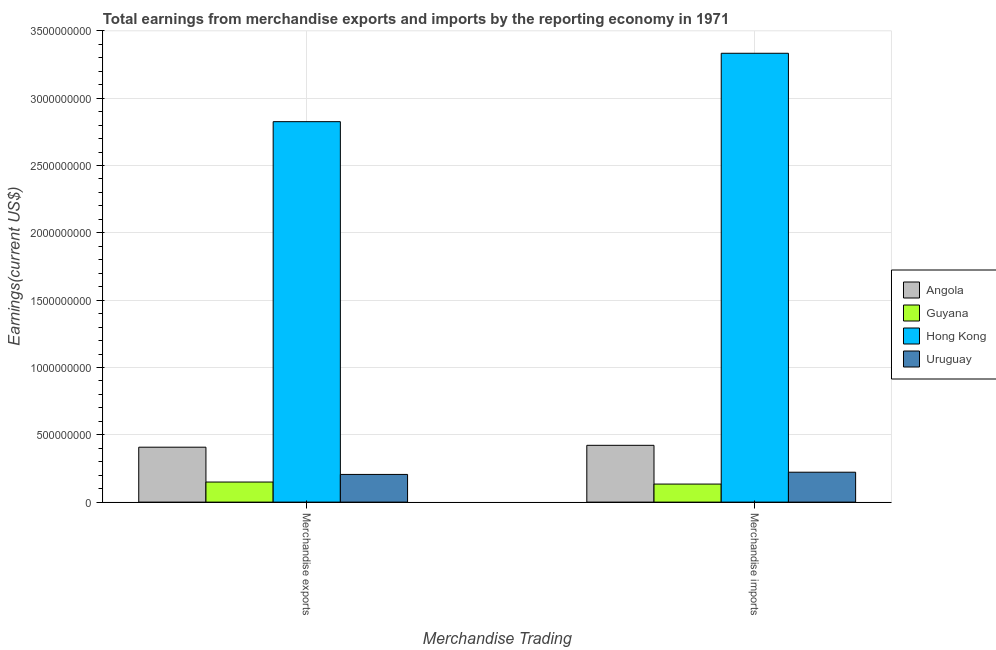How many different coloured bars are there?
Provide a short and direct response. 4. How many groups of bars are there?
Your answer should be very brief. 2. Are the number of bars per tick equal to the number of legend labels?
Your answer should be compact. Yes. Are the number of bars on each tick of the X-axis equal?
Make the answer very short. Yes. What is the label of the 2nd group of bars from the left?
Your answer should be very brief. Merchandise imports. What is the earnings from merchandise imports in Hong Kong?
Your response must be concise. 3.33e+09. Across all countries, what is the maximum earnings from merchandise imports?
Make the answer very short. 3.33e+09. Across all countries, what is the minimum earnings from merchandise exports?
Provide a succinct answer. 1.49e+08. In which country was the earnings from merchandise imports maximum?
Provide a succinct answer. Hong Kong. In which country was the earnings from merchandise exports minimum?
Provide a short and direct response. Guyana. What is the total earnings from merchandise exports in the graph?
Your answer should be very brief. 3.59e+09. What is the difference between the earnings from merchandise imports in Guyana and that in Angola?
Your response must be concise. -2.88e+08. What is the difference between the earnings from merchandise imports in Angola and the earnings from merchandise exports in Uruguay?
Keep it short and to the point. 2.16e+08. What is the average earnings from merchandise imports per country?
Offer a very short reply. 1.03e+09. What is the difference between the earnings from merchandise imports and earnings from merchandise exports in Angola?
Give a very brief answer. 1.39e+07. In how many countries, is the earnings from merchandise exports greater than 600000000 US$?
Offer a terse response. 1. What is the ratio of the earnings from merchandise exports in Uruguay to that in Hong Kong?
Your response must be concise. 0.07. In how many countries, is the earnings from merchandise exports greater than the average earnings from merchandise exports taken over all countries?
Your answer should be very brief. 1. What does the 1st bar from the left in Merchandise exports represents?
Your response must be concise. Angola. What does the 2nd bar from the right in Merchandise imports represents?
Provide a short and direct response. Hong Kong. How many bars are there?
Provide a succinct answer. 8. Are all the bars in the graph horizontal?
Make the answer very short. No. How many countries are there in the graph?
Offer a very short reply. 4. What is the difference between two consecutive major ticks on the Y-axis?
Make the answer very short. 5.00e+08. Are the values on the major ticks of Y-axis written in scientific E-notation?
Provide a succinct answer. No. Does the graph contain any zero values?
Provide a succinct answer. No. Does the graph contain grids?
Offer a very short reply. Yes. How are the legend labels stacked?
Offer a terse response. Vertical. What is the title of the graph?
Offer a terse response. Total earnings from merchandise exports and imports by the reporting economy in 1971. Does "Nepal" appear as one of the legend labels in the graph?
Offer a terse response. No. What is the label or title of the X-axis?
Your answer should be very brief. Merchandise Trading. What is the label or title of the Y-axis?
Ensure brevity in your answer.  Earnings(current US$). What is the Earnings(current US$) in Angola in Merchandise exports?
Ensure brevity in your answer.  4.08e+08. What is the Earnings(current US$) in Guyana in Merchandise exports?
Keep it short and to the point. 1.49e+08. What is the Earnings(current US$) of Hong Kong in Merchandise exports?
Make the answer very short. 2.83e+09. What is the Earnings(current US$) in Uruguay in Merchandise exports?
Provide a short and direct response. 2.06e+08. What is the Earnings(current US$) of Angola in Merchandise imports?
Keep it short and to the point. 4.22e+08. What is the Earnings(current US$) of Guyana in Merchandise imports?
Make the answer very short. 1.34e+08. What is the Earnings(current US$) in Hong Kong in Merchandise imports?
Your response must be concise. 3.33e+09. What is the Earnings(current US$) of Uruguay in Merchandise imports?
Provide a short and direct response. 2.22e+08. Across all Merchandise Trading, what is the maximum Earnings(current US$) in Angola?
Make the answer very short. 4.22e+08. Across all Merchandise Trading, what is the maximum Earnings(current US$) of Guyana?
Make the answer very short. 1.49e+08. Across all Merchandise Trading, what is the maximum Earnings(current US$) of Hong Kong?
Offer a terse response. 3.33e+09. Across all Merchandise Trading, what is the maximum Earnings(current US$) of Uruguay?
Your response must be concise. 2.22e+08. Across all Merchandise Trading, what is the minimum Earnings(current US$) of Angola?
Keep it short and to the point. 4.08e+08. Across all Merchandise Trading, what is the minimum Earnings(current US$) of Guyana?
Keep it short and to the point. 1.34e+08. Across all Merchandise Trading, what is the minimum Earnings(current US$) in Hong Kong?
Your answer should be very brief. 2.83e+09. Across all Merchandise Trading, what is the minimum Earnings(current US$) of Uruguay?
Provide a short and direct response. 2.06e+08. What is the total Earnings(current US$) of Angola in the graph?
Provide a short and direct response. 8.30e+08. What is the total Earnings(current US$) of Guyana in the graph?
Your answer should be compact. 2.83e+08. What is the total Earnings(current US$) of Hong Kong in the graph?
Your response must be concise. 6.16e+09. What is the total Earnings(current US$) of Uruguay in the graph?
Offer a terse response. 4.28e+08. What is the difference between the Earnings(current US$) of Angola in Merchandise exports and that in Merchandise imports?
Provide a short and direct response. -1.39e+07. What is the difference between the Earnings(current US$) in Guyana in Merchandise exports and that in Merchandise imports?
Your response must be concise. 1.51e+07. What is the difference between the Earnings(current US$) in Hong Kong in Merchandise exports and that in Merchandise imports?
Make the answer very short. -5.08e+08. What is the difference between the Earnings(current US$) in Uruguay in Merchandise exports and that in Merchandise imports?
Offer a terse response. -1.65e+07. What is the difference between the Earnings(current US$) in Angola in Merchandise exports and the Earnings(current US$) in Guyana in Merchandise imports?
Ensure brevity in your answer.  2.74e+08. What is the difference between the Earnings(current US$) of Angola in Merchandise exports and the Earnings(current US$) of Hong Kong in Merchandise imports?
Give a very brief answer. -2.93e+09. What is the difference between the Earnings(current US$) in Angola in Merchandise exports and the Earnings(current US$) in Uruguay in Merchandise imports?
Your answer should be compact. 1.86e+08. What is the difference between the Earnings(current US$) of Guyana in Merchandise exports and the Earnings(current US$) of Hong Kong in Merchandise imports?
Make the answer very short. -3.18e+09. What is the difference between the Earnings(current US$) in Guyana in Merchandise exports and the Earnings(current US$) in Uruguay in Merchandise imports?
Make the answer very short. -7.30e+07. What is the difference between the Earnings(current US$) in Hong Kong in Merchandise exports and the Earnings(current US$) in Uruguay in Merchandise imports?
Provide a succinct answer. 2.60e+09. What is the average Earnings(current US$) in Angola per Merchandise Trading?
Ensure brevity in your answer.  4.15e+08. What is the average Earnings(current US$) of Guyana per Merchandise Trading?
Keep it short and to the point. 1.42e+08. What is the average Earnings(current US$) in Hong Kong per Merchandise Trading?
Provide a short and direct response. 3.08e+09. What is the average Earnings(current US$) in Uruguay per Merchandise Trading?
Offer a very short reply. 2.14e+08. What is the difference between the Earnings(current US$) in Angola and Earnings(current US$) in Guyana in Merchandise exports?
Your answer should be very brief. 2.59e+08. What is the difference between the Earnings(current US$) in Angola and Earnings(current US$) in Hong Kong in Merchandise exports?
Provide a succinct answer. -2.42e+09. What is the difference between the Earnings(current US$) of Angola and Earnings(current US$) of Uruguay in Merchandise exports?
Provide a succinct answer. 2.02e+08. What is the difference between the Earnings(current US$) of Guyana and Earnings(current US$) of Hong Kong in Merchandise exports?
Make the answer very short. -2.68e+09. What is the difference between the Earnings(current US$) of Guyana and Earnings(current US$) of Uruguay in Merchandise exports?
Give a very brief answer. -5.65e+07. What is the difference between the Earnings(current US$) in Hong Kong and Earnings(current US$) in Uruguay in Merchandise exports?
Make the answer very short. 2.62e+09. What is the difference between the Earnings(current US$) of Angola and Earnings(current US$) of Guyana in Merchandise imports?
Your response must be concise. 2.88e+08. What is the difference between the Earnings(current US$) of Angola and Earnings(current US$) of Hong Kong in Merchandise imports?
Keep it short and to the point. -2.91e+09. What is the difference between the Earnings(current US$) of Angola and Earnings(current US$) of Uruguay in Merchandise imports?
Your answer should be very brief. 2.00e+08. What is the difference between the Earnings(current US$) of Guyana and Earnings(current US$) of Hong Kong in Merchandise imports?
Provide a succinct answer. -3.20e+09. What is the difference between the Earnings(current US$) in Guyana and Earnings(current US$) in Uruguay in Merchandise imports?
Your response must be concise. -8.81e+07. What is the difference between the Earnings(current US$) in Hong Kong and Earnings(current US$) in Uruguay in Merchandise imports?
Provide a succinct answer. 3.11e+09. What is the ratio of the Earnings(current US$) in Angola in Merchandise exports to that in Merchandise imports?
Your answer should be compact. 0.97. What is the ratio of the Earnings(current US$) in Guyana in Merchandise exports to that in Merchandise imports?
Your answer should be compact. 1.11. What is the ratio of the Earnings(current US$) in Hong Kong in Merchandise exports to that in Merchandise imports?
Your answer should be very brief. 0.85. What is the ratio of the Earnings(current US$) of Uruguay in Merchandise exports to that in Merchandise imports?
Provide a short and direct response. 0.93. What is the difference between the highest and the second highest Earnings(current US$) in Angola?
Ensure brevity in your answer.  1.39e+07. What is the difference between the highest and the second highest Earnings(current US$) of Guyana?
Your answer should be very brief. 1.51e+07. What is the difference between the highest and the second highest Earnings(current US$) in Hong Kong?
Ensure brevity in your answer.  5.08e+08. What is the difference between the highest and the second highest Earnings(current US$) of Uruguay?
Offer a very short reply. 1.65e+07. What is the difference between the highest and the lowest Earnings(current US$) of Angola?
Your answer should be very brief. 1.39e+07. What is the difference between the highest and the lowest Earnings(current US$) in Guyana?
Ensure brevity in your answer.  1.51e+07. What is the difference between the highest and the lowest Earnings(current US$) in Hong Kong?
Provide a short and direct response. 5.08e+08. What is the difference between the highest and the lowest Earnings(current US$) in Uruguay?
Give a very brief answer. 1.65e+07. 